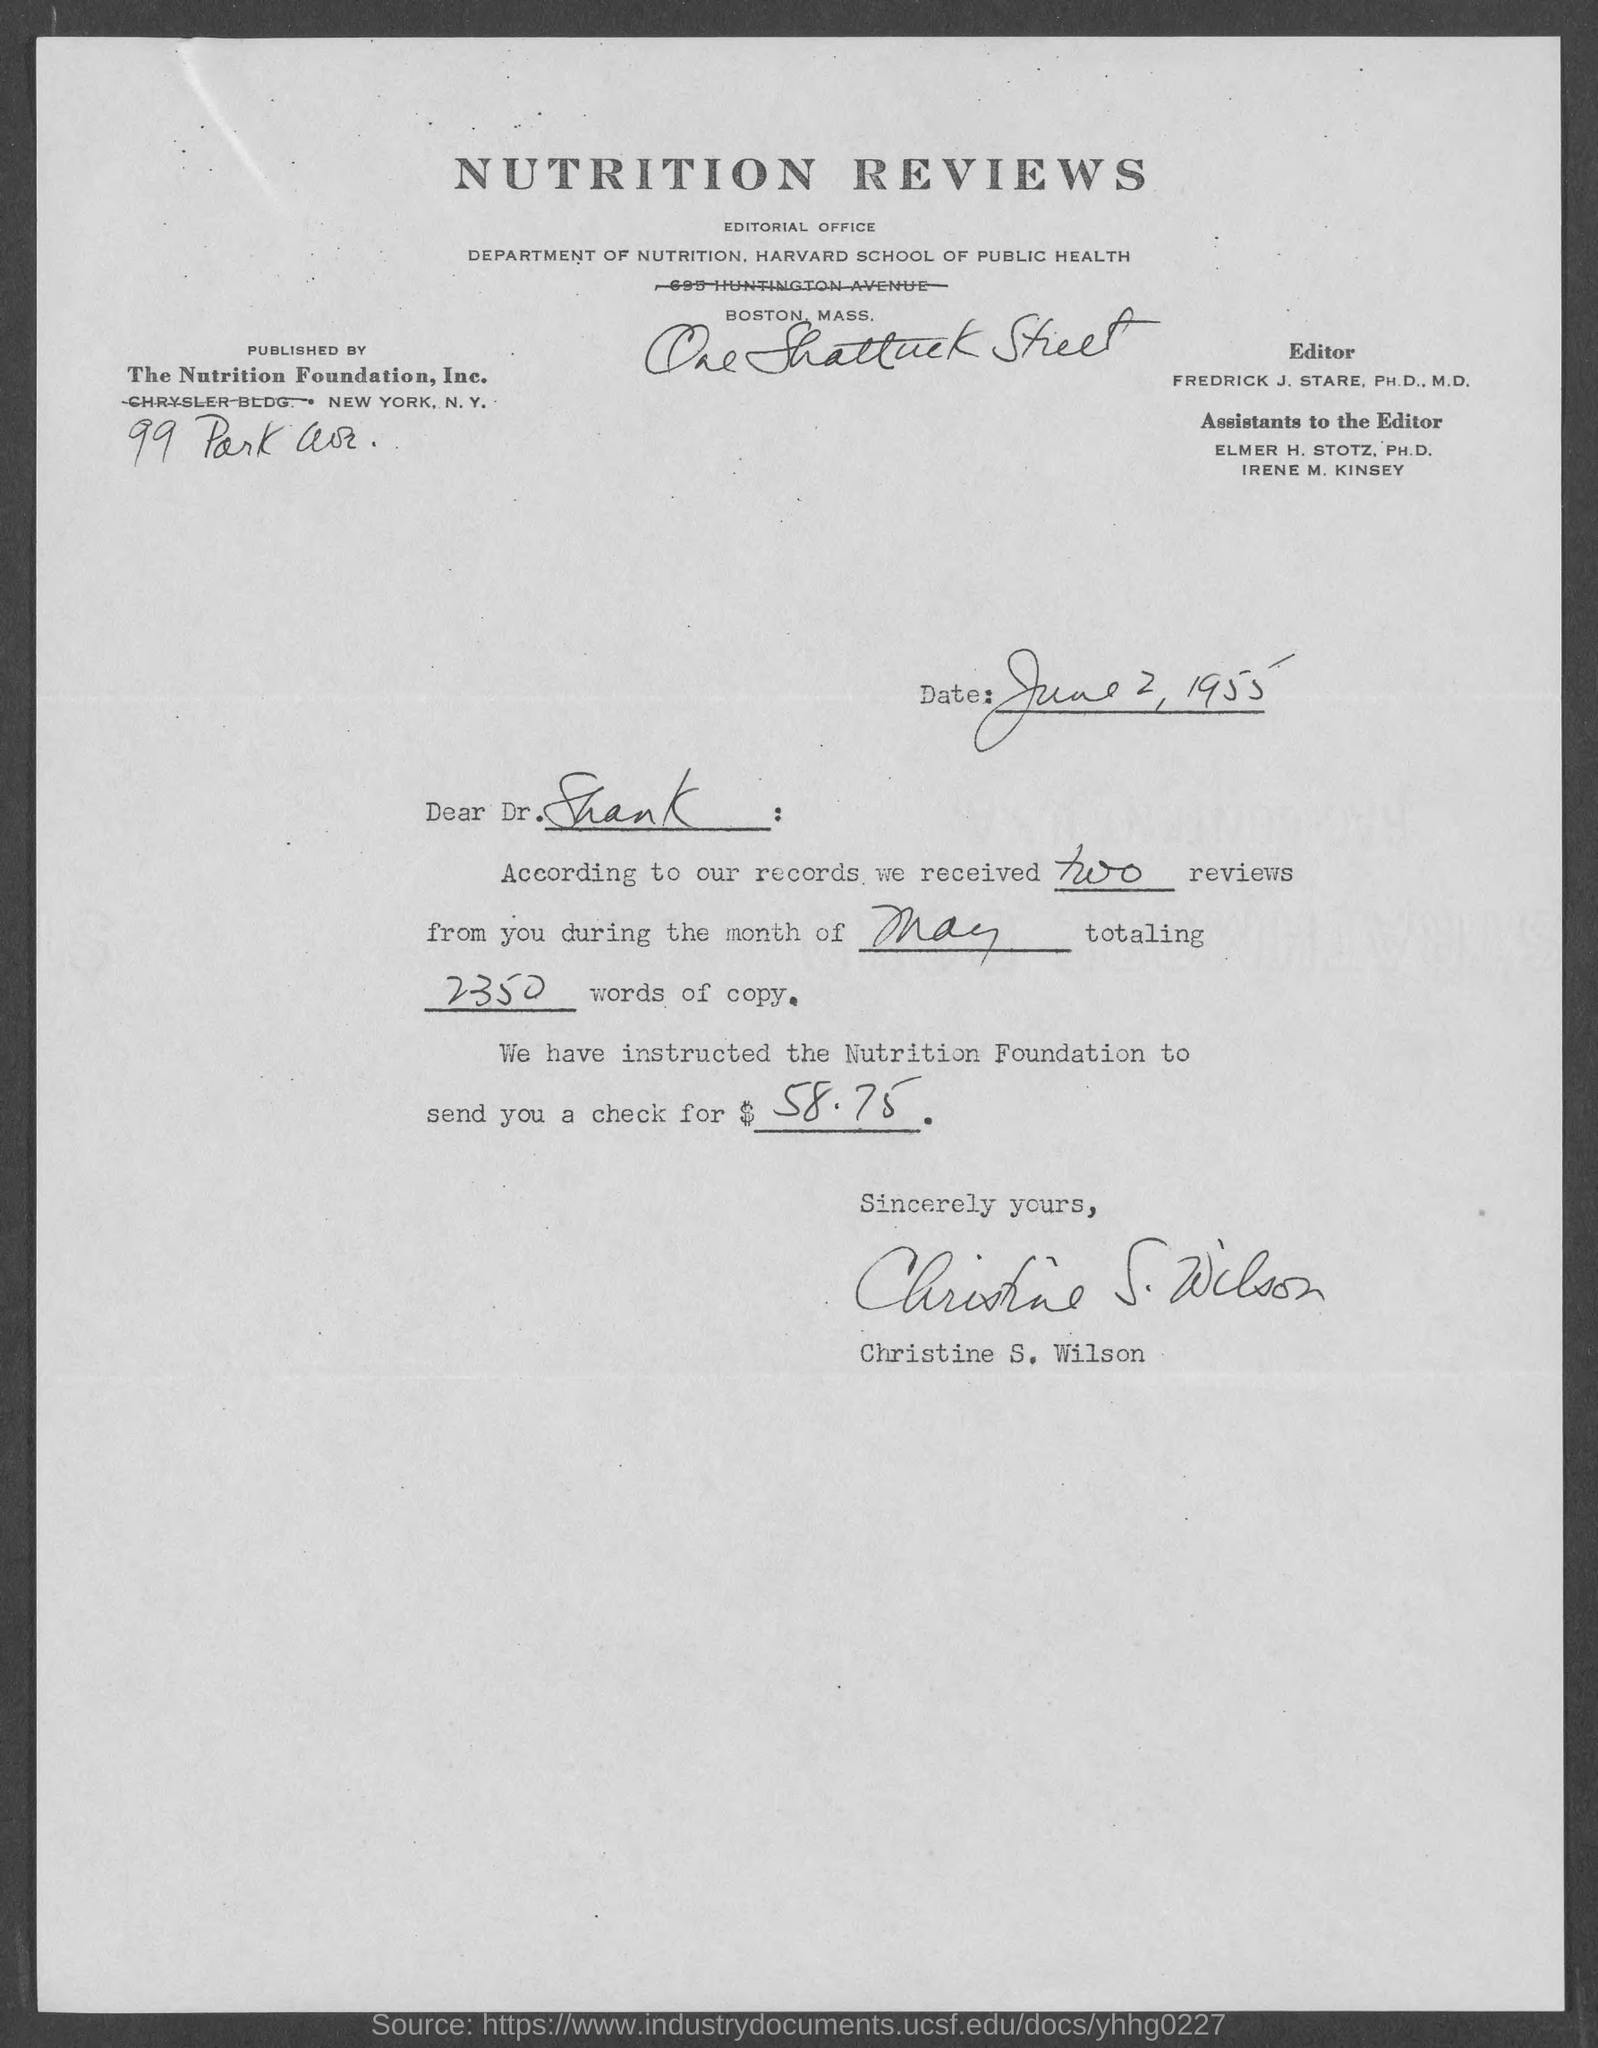Point out several critical features in this image. For which month have the reviews been conducted? This letter is addressed to Dr. Shank. Two reviews have been received. The date on the document is June 2, 1955. The amount of the check is $58.75. 